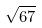Convert formula to latex. <formula><loc_0><loc_0><loc_500><loc_500>\sqrt { 6 7 }</formula> 